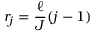<formula> <loc_0><loc_0><loc_500><loc_500>r _ { j } = \frac { \ell } { J } ( j - 1 )</formula> 